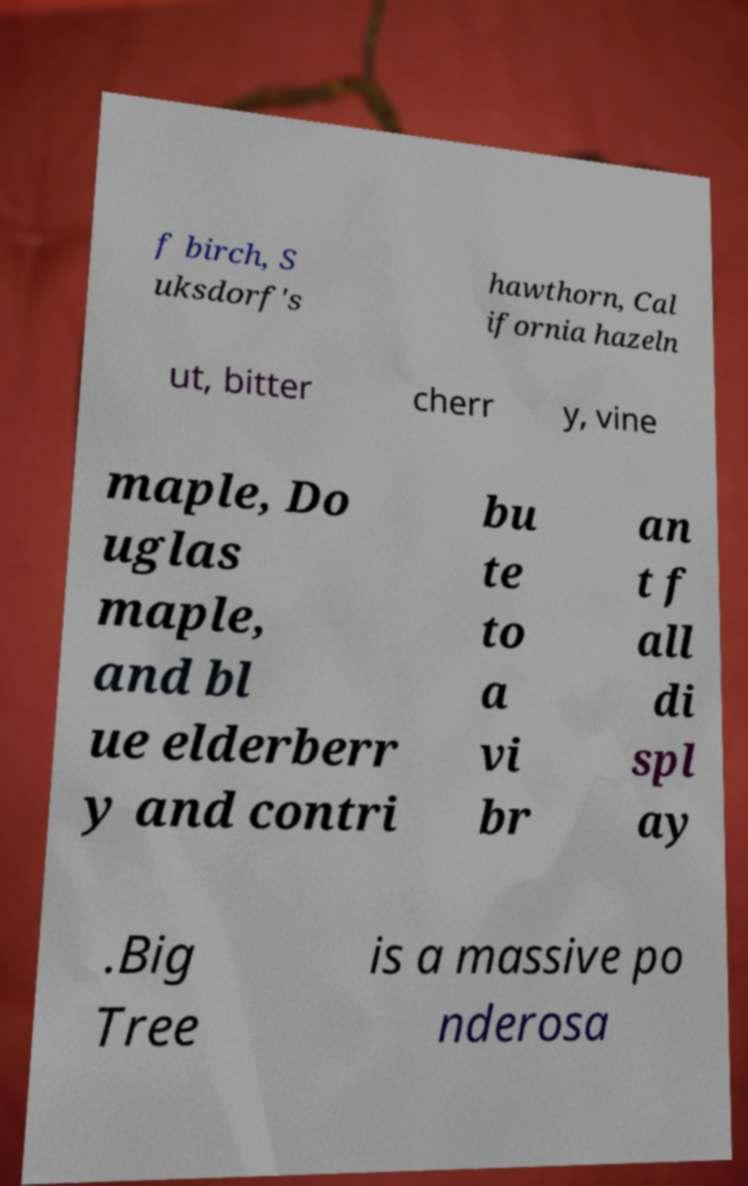I need the written content from this picture converted into text. Can you do that? f birch, S uksdorf's hawthorn, Cal ifornia hazeln ut, bitter cherr y, vine maple, Do uglas maple, and bl ue elderberr y and contri bu te to a vi br an t f all di spl ay .Big Tree is a massive po nderosa 